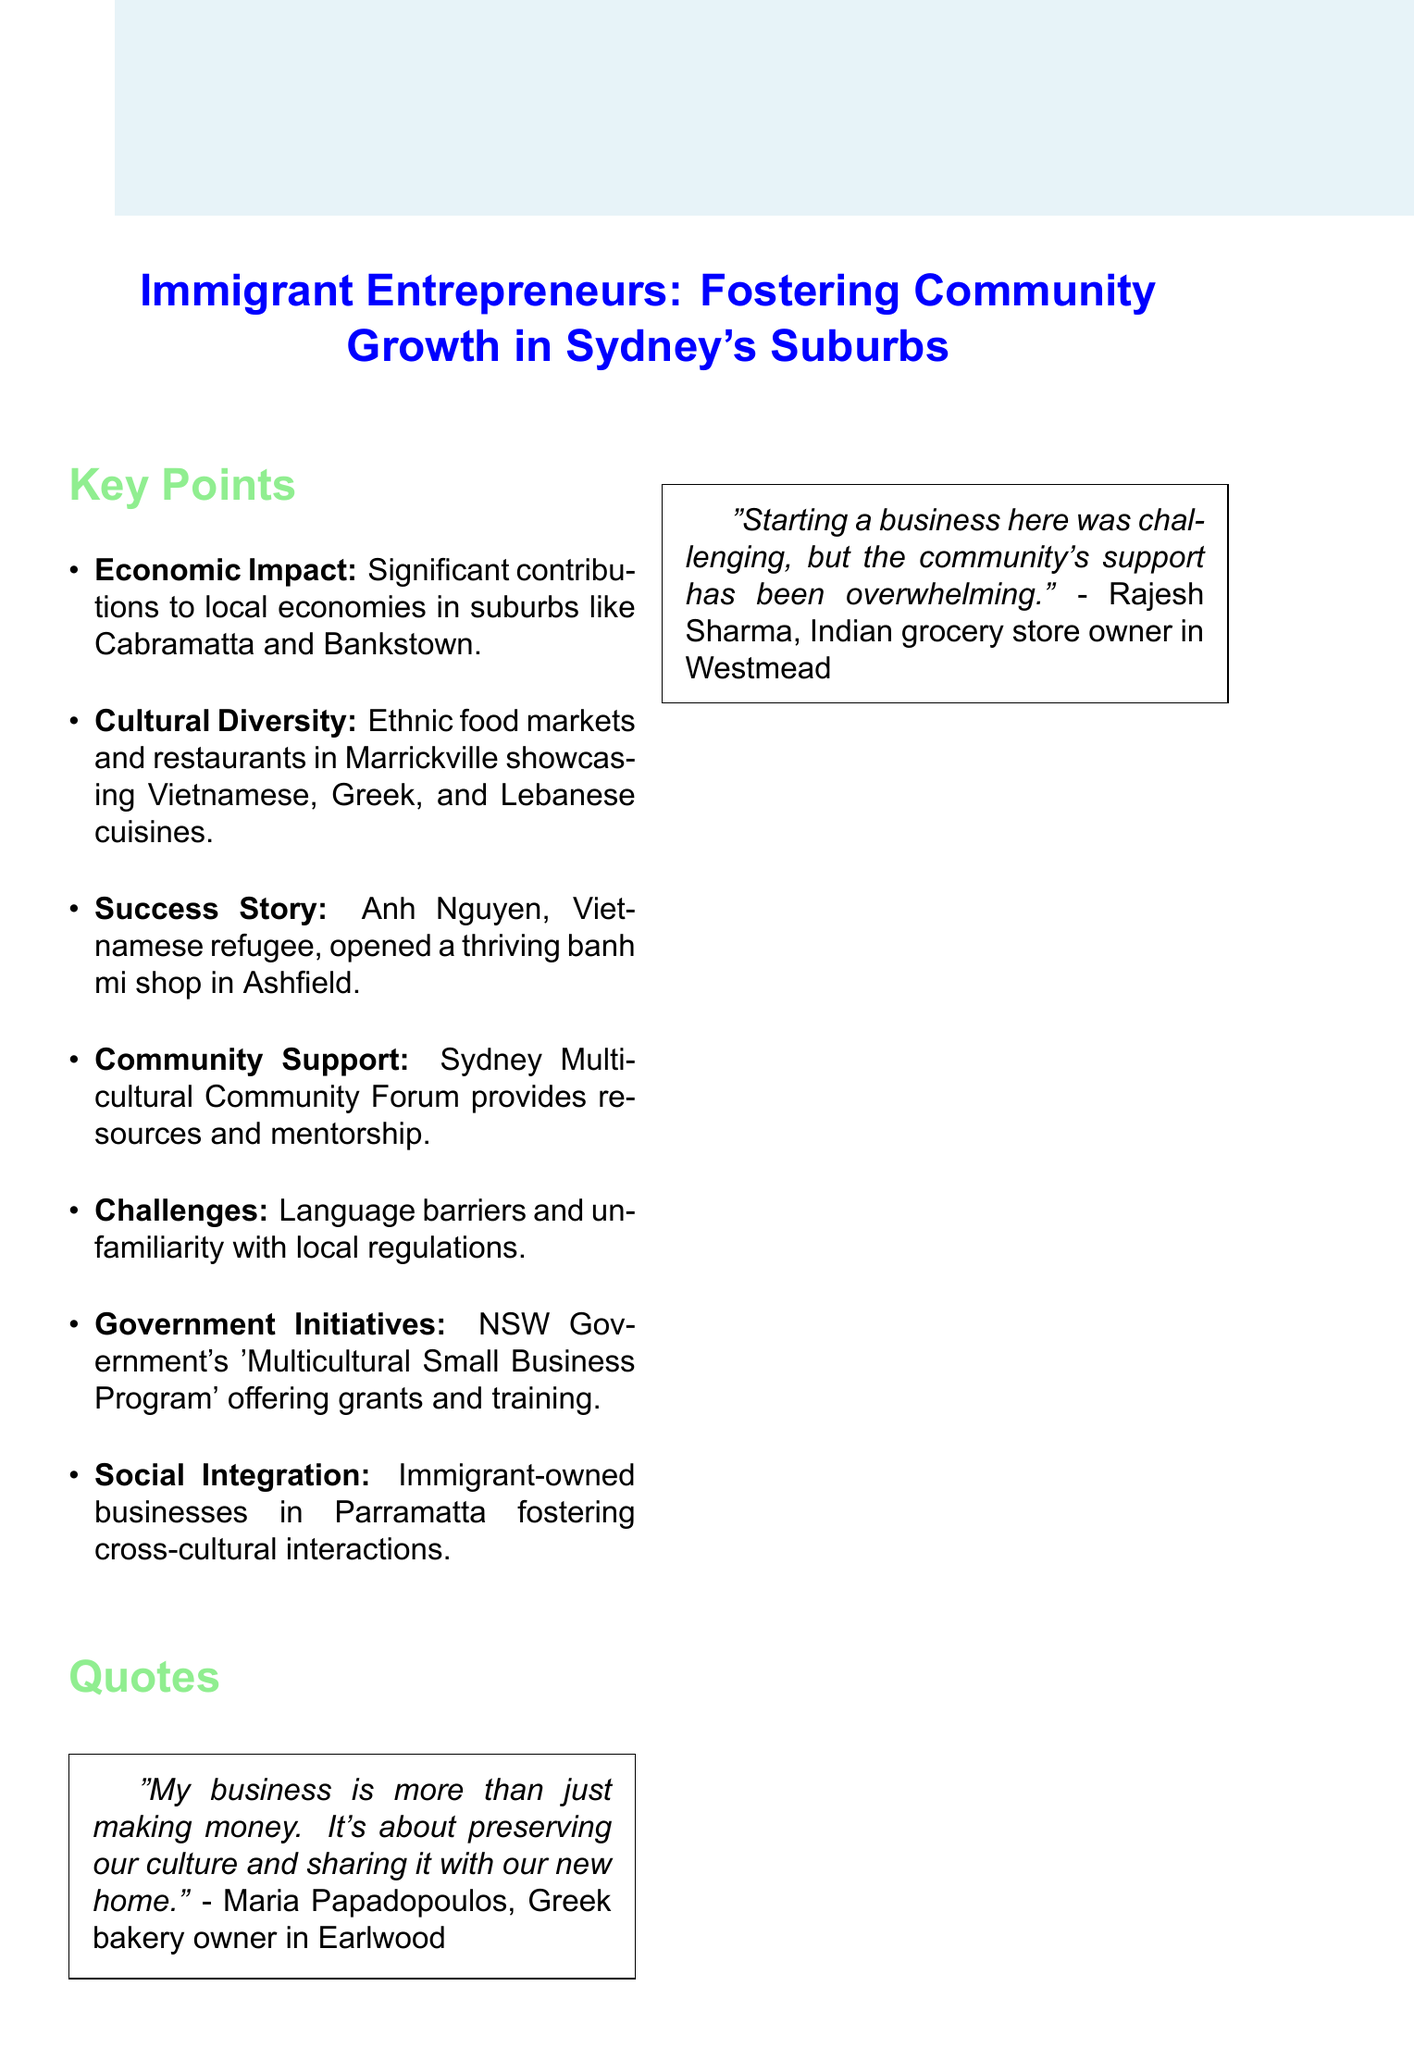What is the title of the document? The title is prominently displayed at the beginning of the document.
Answer: Immigrant Entrepreneurs: Fostering Community Growth in Sydney's Suburbs What is the economic impact mentioned in the document? The document states that small businesses have significant contributions to the local economy in specific suburbs.
Answer: Significant contributions to local economy Who is the highlighted success story in the notes? The document profiles an individual who opened a thriving banh mi shop.
Answer: Anh Nguyen What percentage of small business owners in Western Sydney are first-generation immigrants? This statistic is provided in the data point section of the document.
Answer: 37% What type of support does the Sydney Multicultural Community Forum provide? The document mentions the provision of resources and mentorship for new immigrant business owners.
Answer: Resources and mentorship What challenges do immigrant entrepreneurs face according to the document? The document lists common hurdles encountered by these entrepreneurs.
Answer: Language barriers and unfamiliarity with local regulations What government initiative supports immigrant-owned startups? The document references a specific program initiated by the NSW Government for this purpose.
Answer: Multicultural Small Business Program What potential angle is suggested for further exploration? This angle is highlighted at the end of the document, summarizing the broader social implications.
Answer: Contributing to peaceful coexistence and cultural exchange 